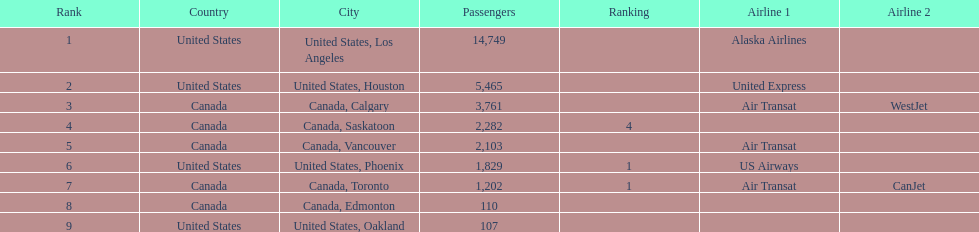The difference in passengers between los angeles and toronto 13,547. 